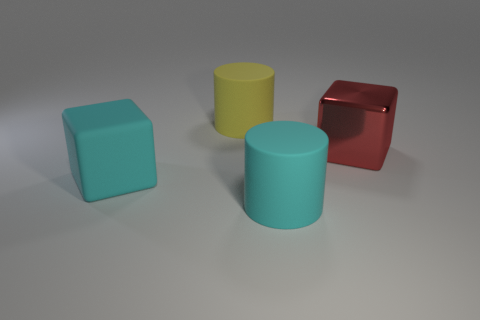What size is the object that is to the left of the large cyan cylinder and in front of the yellow cylinder?
Ensure brevity in your answer.  Large. There is a rubber thing that is the same color as the rubber cube; what is its shape?
Offer a terse response. Cylinder. Do the large matte cube and the cylinder in front of the big metallic cube have the same color?
Your answer should be very brief. Yes. What is the size of the matte cylinder that is the same color as the large matte cube?
Keep it short and to the point. Large. There is a big object that is both on the right side of the yellow thing and to the left of the shiny object; what shape is it?
Your response must be concise. Cylinder. Are there any big cyan objects to the right of the cyan cube?
Offer a terse response. Yes. There is another cyan thing that is the same shape as the large metallic object; what size is it?
Make the answer very short. Large. There is a cyan cylinder to the left of the cube that is to the right of the large cyan cylinder; how big is it?
Provide a short and direct response. Large. What color is the other object that is the same shape as the big metallic object?
Your answer should be compact. Cyan. How many large matte cylinders have the same color as the metallic thing?
Offer a very short reply. 0. 